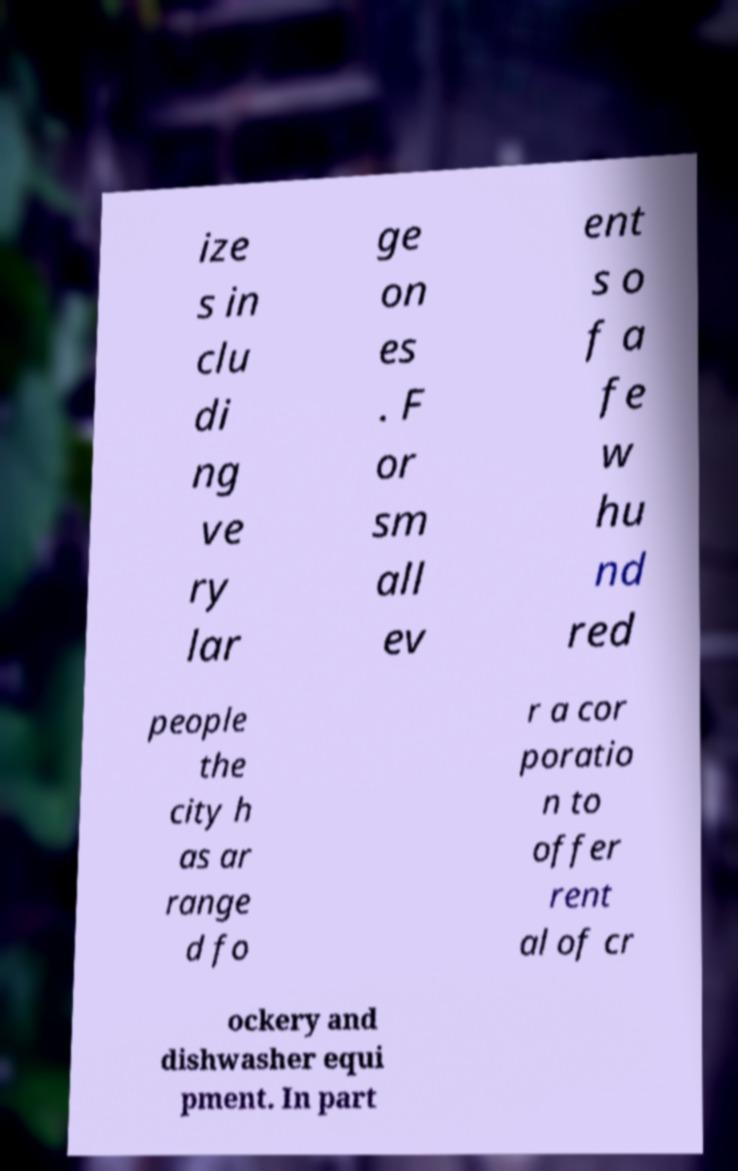What messages or text are displayed in this image? I need them in a readable, typed format. ize s in clu di ng ve ry lar ge on es . F or sm all ev ent s o f a fe w hu nd red people the city h as ar range d fo r a cor poratio n to offer rent al of cr ockery and dishwasher equi pment. In part 